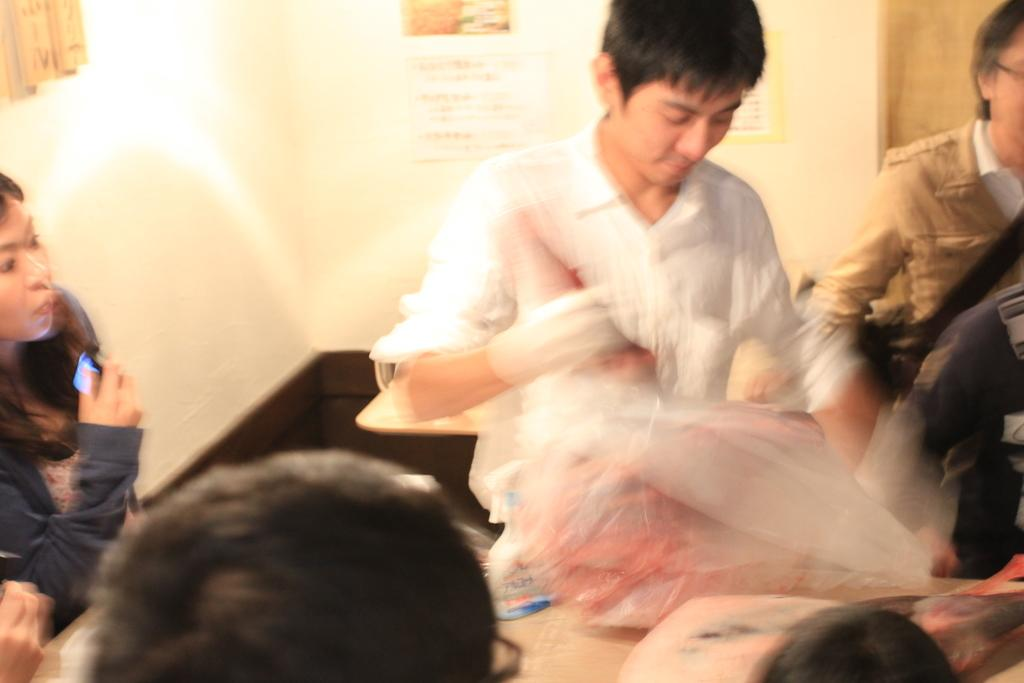What are the people in the image doing? The people in the image are standing and sitting. Can you describe what one person is holding? One person is holding a cover. How is the cover depicted in the image? The cover is blurred. What can be seen in the background of the image? There are posts attached to the wall in the background of the image. What type of quill is being used by the person sitting in the image? There is no quill present in the image. In which bedroom is the scene taking place? The image does not depict a bedroom, so it cannot be determined where the scene is taking place. 